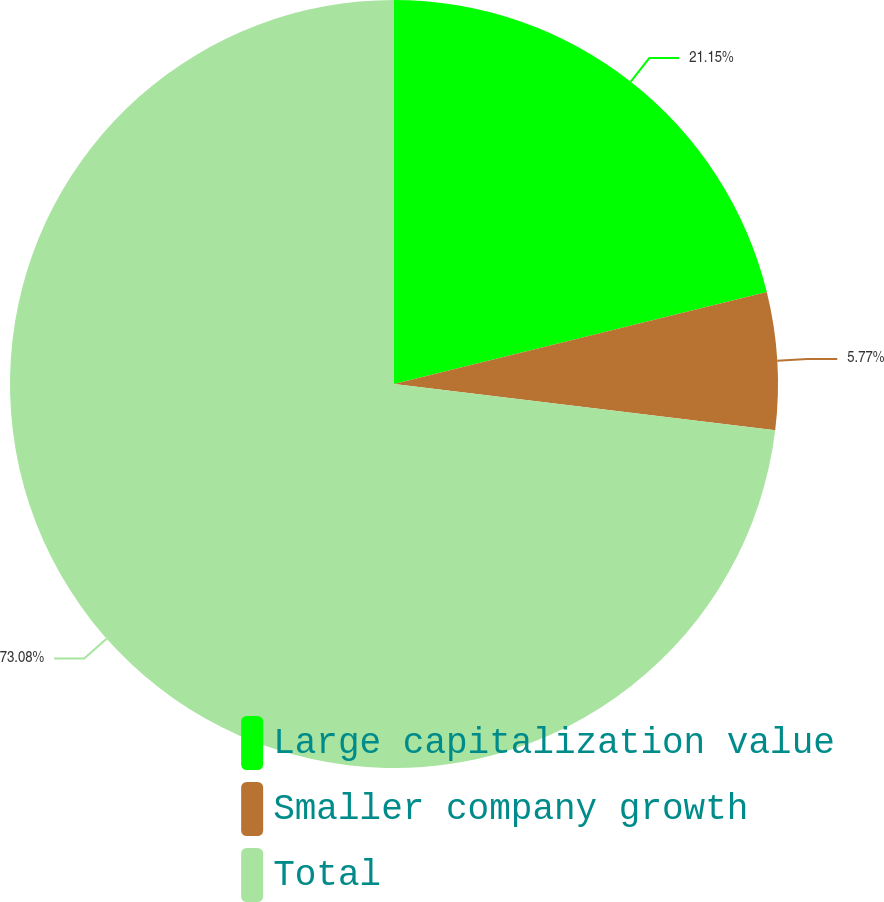Convert chart. <chart><loc_0><loc_0><loc_500><loc_500><pie_chart><fcel>Large capitalization value<fcel>Smaller company growth<fcel>Total<nl><fcel>21.15%<fcel>5.77%<fcel>73.08%<nl></chart> 